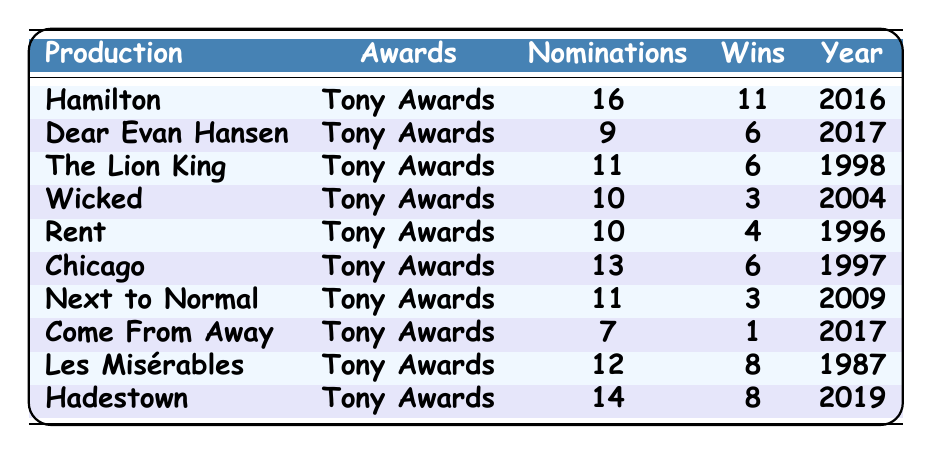What production had the most Tony Award nominations? "Hamilton" had the most nominations with a total of 16, which can be directly seen in the nominations column.
Answer: Hamilton Which production won the least number of Tony Awards? "Come From Away" won only 1 Tony Award, the lowest win in the table. This is confirmed by comparing the wins across all productions.
Answer: Come From Away How many total nominations did all productions combined receive? To find the total nominations, add the nominations for each production: 16 + 9 + 11 + 10 + 10 + 13 + 11 + 7 + 12 + 14 =  6 + 6 = 22 + 11 + 10 + 7 = 31 + 12 + 14 = 45.
Answer: 86 Is it true that "Next to Normal" won more Tony Awards than "Wicked"? "Next to Normal" won 3 Tony Awards while "Wicked" won 3 as well. Therefore, they won the same number of awards.
Answer: No What is the average number of wins for the productions listed? To find the average, sum the wins: 11 + 6 + 6 + 3 + 4 + 6 + 3 + 1 + 8 + 8 = 56. Count the number of productions, which is 10. Divide: 56 / 10 = 5.6.
Answer: 5.6 Which year saw the highest number of nominations for any production? "Hamilton" received the highest nominations in 2016 with 16 nominations, which is the maximum listed in the nominations column.
Answer: 2016 How many more wins did "Hamilton" have than "Les Misérables"? "Hamilton" won 11 Tony Awards while "Les Misérables" won 8. The difference is 11 - 8 = 3 wins more for "Hamilton".
Answer: 3 In how many years did productions receive more than 10 nominations? "Hamilton", "The Lion King", "Chicago", "Hadestown" received more than 10 nominations. That totals to 4 productions.
Answer: 4 Which production had a higher win to nomination ratio: "Chicago" or "Wicked"? "Chicago" had 6 wins out of 13 nominations (ratio: 6/13), while "Wicked" had 3 wins out of 10 nominations (ratio: 3/10). Calculating the ratios gives approximately 0.46 for "Chicago" and 0.30 for "Wicked". Therefore, "Chicago" has a higher ratio.
Answer: Chicago 